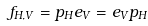<formula> <loc_0><loc_0><loc_500><loc_500>f _ { H , V } = p _ { H } e _ { V } = e _ { V } p _ { H }</formula> 